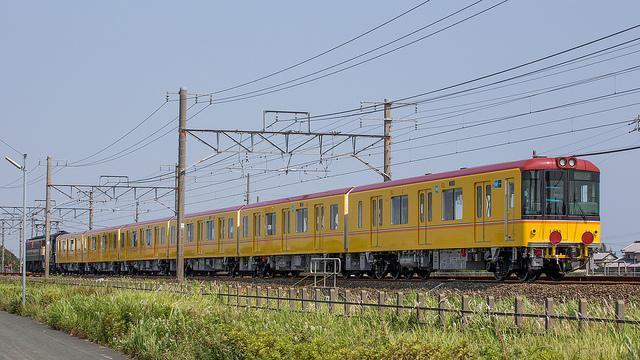How many of the dogs are black?
Give a very brief answer. 0. 